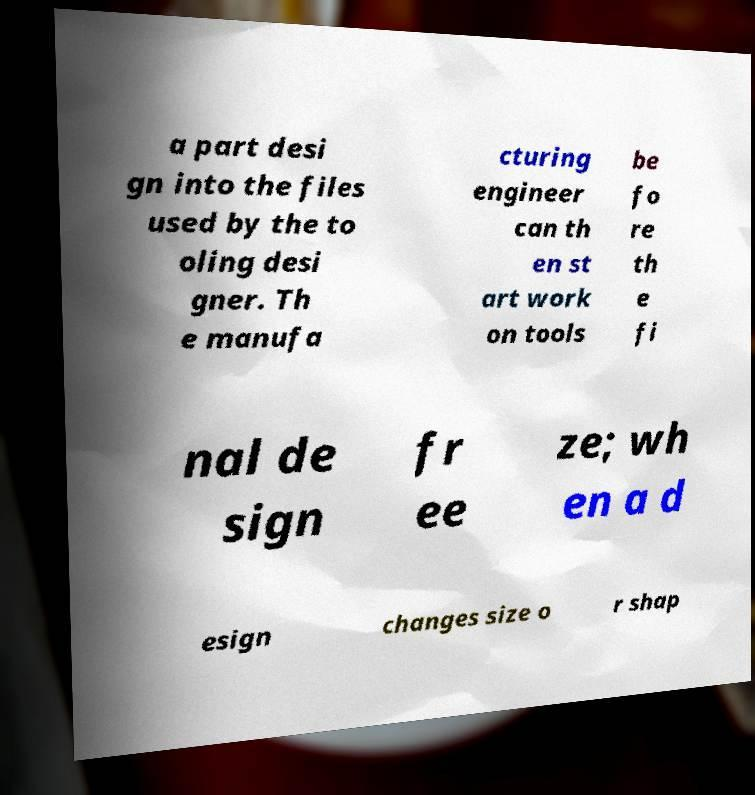What messages or text are displayed in this image? I need them in a readable, typed format. a part desi gn into the files used by the to oling desi gner. Th e manufa cturing engineer can th en st art work on tools be fo re th e fi nal de sign fr ee ze; wh en a d esign changes size o r shap 